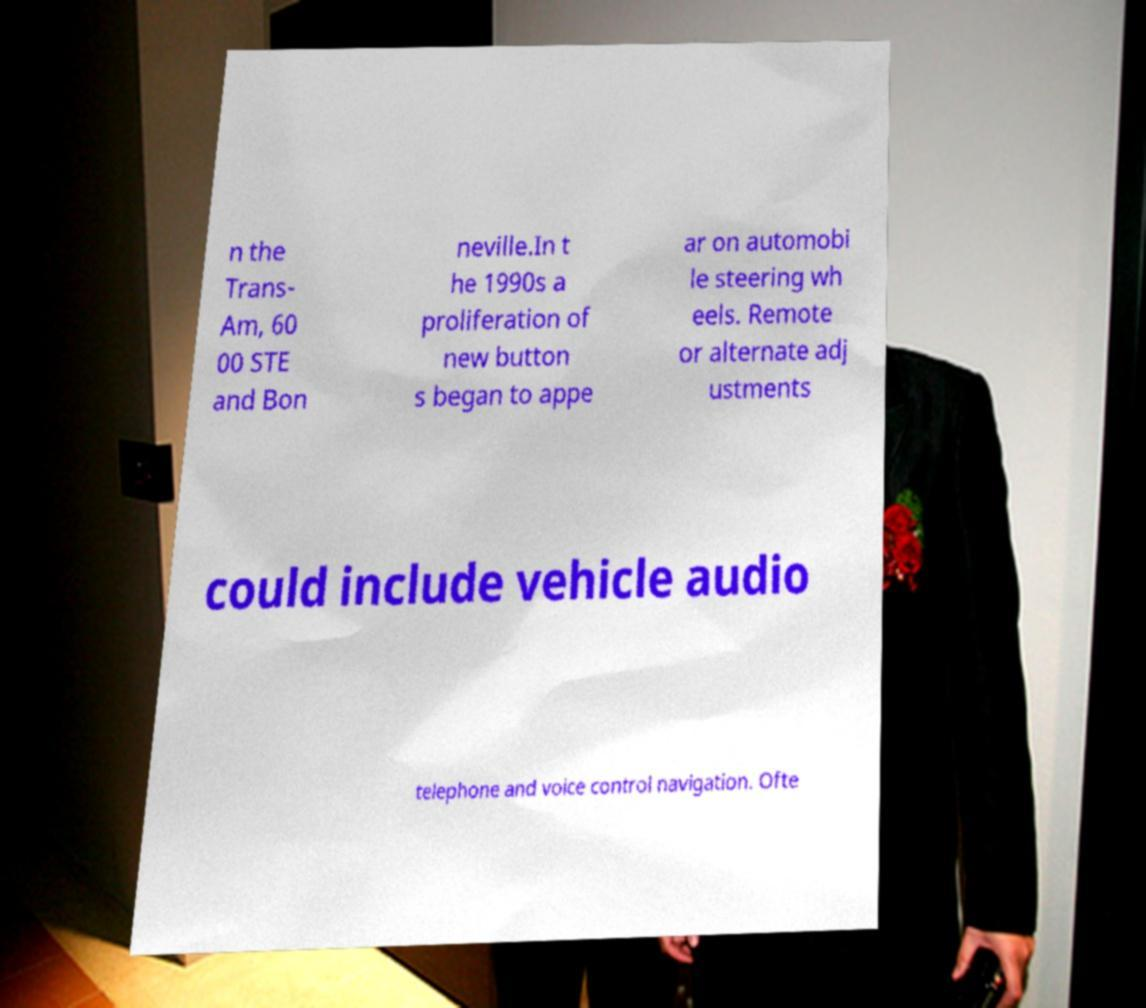There's text embedded in this image that I need extracted. Can you transcribe it verbatim? n the Trans- Am, 60 00 STE and Bon neville.In t he 1990s a proliferation of new button s began to appe ar on automobi le steering wh eels. Remote or alternate adj ustments could include vehicle audio telephone and voice control navigation. Ofte 